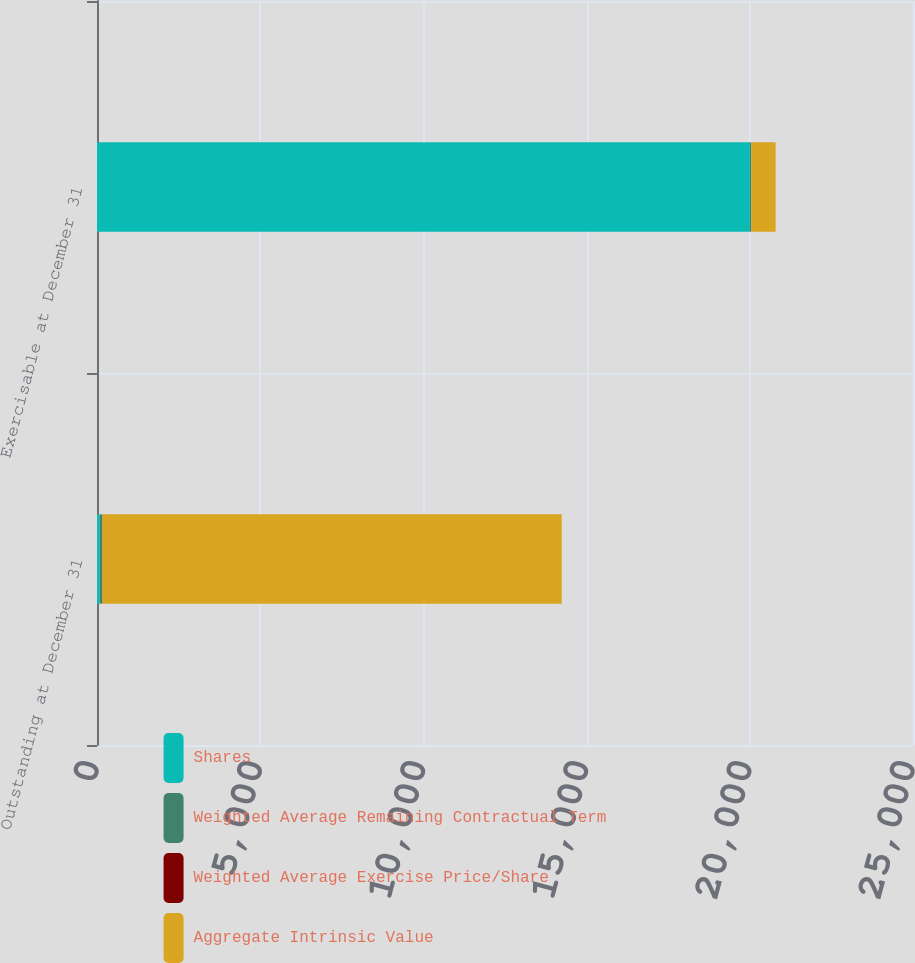Convert chart. <chart><loc_0><loc_0><loc_500><loc_500><stacked_bar_chart><ecel><fcel>Outstanding at December 31<fcel>Exercisable at December 31<nl><fcel>Shares<fcel>80.075<fcel>20000<nl><fcel>Weighted Average Remaining Contractual Term<fcel>80.29<fcel>48.01<nl><fcel>Weighted Average Exercise Price/Share<fcel>5.9<fcel>0.7<nl><fcel>Aggregate Intrinsic Value<fcel>14072<fcel>742<nl></chart> 